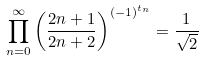Convert formula to latex. <formula><loc_0><loc_0><loc_500><loc_500>\prod _ { n = 0 } ^ { \infty } \left ( \frac { 2 n + 1 } { 2 n + 2 } \right ) ^ { ( - 1 ) ^ { t _ { n } } } = \frac { 1 } { \sqrt { 2 } }</formula> 